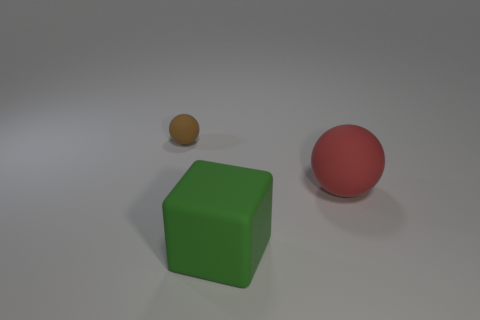What is the color of the other large object that is the same shape as the brown rubber object? The large object that shares its spherical shape with the brown rubber sphere is red in color. 